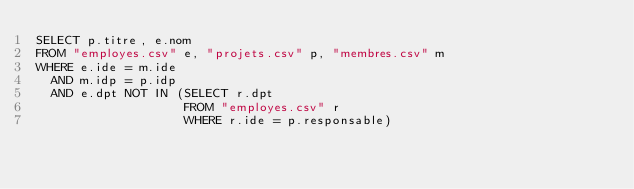Convert code to text. <code><loc_0><loc_0><loc_500><loc_500><_SQL_>SELECT p.titre, e.nom
FROM "employes.csv" e, "projets.csv" p, "membres.csv" m
WHERE e.ide = m.ide
  AND m.idp = p.idp
  AND e.dpt NOT IN (SELECT r.dpt
                    FROM "employes.csv" r
                    WHERE r.ide = p.responsable)
                    
</code> 